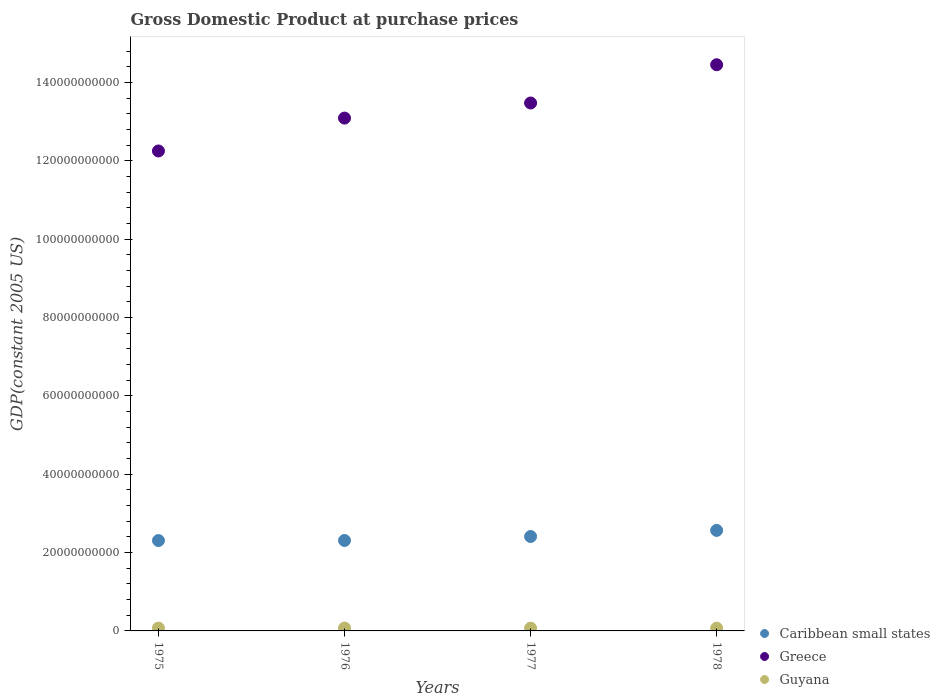How many different coloured dotlines are there?
Make the answer very short. 3. What is the GDP at purchase prices in Caribbean small states in 1976?
Keep it short and to the point. 2.31e+1. Across all years, what is the maximum GDP at purchase prices in Guyana?
Keep it short and to the point. 7.30e+08. Across all years, what is the minimum GDP at purchase prices in Guyana?
Your answer should be very brief. 6.98e+08. In which year was the GDP at purchase prices in Greece maximum?
Provide a succinct answer. 1978. In which year was the GDP at purchase prices in Greece minimum?
Ensure brevity in your answer.  1975. What is the total GDP at purchase prices in Guyana in the graph?
Your response must be concise. 2.86e+09. What is the difference between the GDP at purchase prices in Greece in 1976 and that in 1977?
Offer a very short reply. -3.85e+09. What is the difference between the GDP at purchase prices in Caribbean small states in 1975 and the GDP at purchase prices in Guyana in 1978?
Provide a succinct answer. 2.24e+1. What is the average GDP at purchase prices in Guyana per year?
Offer a very short reply. 7.14e+08. In the year 1976, what is the difference between the GDP at purchase prices in Caribbean small states and GDP at purchase prices in Greece?
Provide a succinct answer. -1.08e+11. What is the ratio of the GDP at purchase prices in Guyana in 1976 to that in 1978?
Keep it short and to the point. 1.05. Is the difference between the GDP at purchase prices in Caribbean small states in 1976 and 1978 greater than the difference between the GDP at purchase prices in Greece in 1976 and 1978?
Keep it short and to the point. Yes. What is the difference between the highest and the second highest GDP at purchase prices in Caribbean small states?
Offer a terse response. 1.56e+09. What is the difference between the highest and the lowest GDP at purchase prices in Caribbean small states?
Your answer should be compact. 2.59e+09. Is the sum of the GDP at purchase prices in Greece in 1975 and 1977 greater than the maximum GDP at purchase prices in Guyana across all years?
Offer a very short reply. Yes. Is the GDP at purchase prices in Guyana strictly less than the GDP at purchase prices in Greece over the years?
Your answer should be compact. Yes. What is the difference between two consecutive major ticks on the Y-axis?
Provide a succinct answer. 2.00e+1. Are the values on the major ticks of Y-axis written in scientific E-notation?
Provide a succinct answer. No. Does the graph contain any zero values?
Give a very brief answer. No. How many legend labels are there?
Your answer should be compact. 3. What is the title of the graph?
Provide a succinct answer. Gross Domestic Product at purchase prices. Does "Liberia" appear as one of the legend labels in the graph?
Give a very brief answer. No. What is the label or title of the X-axis?
Your answer should be very brief. Years. What is the label or title of the Y-axis?
Offer a terse response. GDP(constant 2005 US). What is the GDP(constant 2005 US) of Caribbean small states in 1975?
Keep it short and to the point. 2.31e+1. What is the GDP(constant 2005 US) in Greece in 1975?
Your answer should be compact. 1.23e+11. What is the GDP(constant 2005 US) of Guyana in 1975?
Ensure brevity in your answer.  7.19e+08. What is the GDP(constant 2005 US) of Caribbean small states in 1976?
Give a very brief answer. 2.31e+1. What is the GDP(constant 2005 US) in Greece in 1976?
Offer a terse response. 1.31e+11. What is the GDP(constant 2005 US) of Guyana in 1976?
Your response must be concise. 7.30e+08. What is the GDP(constant 2005 US) of Caribbean small states in 1977?
Offer a very short reply. 2.41e+1. What is the GDP(constant 2005 US) in Greece in 1977?
Your answer should be compact. 1.35e+11. What is the GDP(constant 2005 US) in Guyana in 1977?
Your answer should be compact. 7.11e+08. What is the GDP(constant 2005 US) of Caribbean small states in 1978?
Offer a terse response. 2.57e+1. What is the GDP(constant 2005 US) of Greece in 1978?
Your answer should be compact. 1.45e+11. What is the GDP(constant 2005 US) in Guyana in 1978?
Your response must be concise. 6.98e+08. Across all years, what is the maximum GDP(constant 2005 US) of Caribbean small states?
Your answer should be very brief. 2.57e+1. Across all years, what is the maximum GDP(constant 2005 US) of Greece?
Your response must be concise. 1.45e+11. Across all years, what is the maximum GDP(constant 2005 US) of Guyana?
Ensure brevity in your answer.  7.30e+08. Across all years, what is the minimum GDP(constant 2005 US) of Caribbean small states?
Your response must be concise. 2.31e+1. Across all years, what is the minimum GDP(constant 2005 US) of Greece?
Ensure brevity in your answer.  1.23e+11. Across all years, what is the minimum GDP(constant 2005 US) in Guyana?
Make the answer very short. 6.98e+08. What is the total GDP(constant 2005 US) in Caribbean small states in the graph?
Your response must be concise. 9.59e+1. What is the total GDP(constant 2005 US) in Greece in the graph?
Make the answer very short. 5.33e+11. What is the total GDP(constant 2005 US) of Guyana in the graph?
Keep it short and to the point. 2.86e+09. What is the difference between the GDP(constant 2005 US) of Caribbean small states in 1975 and that in 1976?
Your answer should be compact. -1.95e+07. What is the difference between the GDP(constant 2005 US) of Greece in 1975 and that in 1976?
Make the answer very short. -8.40e+09. What is the difference between the GDP(constant 2005 US) in Guyana in 1975 and that in 1976?
Your answer should be compact. -1.10e+07. What is the difference between the GDP(constant 2005 US) of Caribbean small states in 1975 and that in 1977?
Make the answer very short. -1.03e+09. What is the difference between the GDP(constant 2005 US) of Greece in 1975 and that in 1977?
Your answer should be very brief. -1.22e+1. What is the difference between the GDP(constant 2005 US) of Guyana in 1975 and that in 1977?
Offer a very short reply. 8.21e+06. What is the difference between the GDP(constant 2005 US) in Caribbean small states in 1975 and that in 1978?
Offer a terse response. -2.59e+09. What is the difference between the GDP(constant 2005 US) in Greece in 1975 and that in 1978?
Your response must be concise. -2.20e+1. What is the difference between the GDP(constant 2005 US) of Guyana in 1975 and that in 1978?
Make the answer very short. 2.10e+07. What is the difference between the GDP(constant 2005 US) of Caribbean small states in 1976 and that in 1977?
Your response must be concise. -1.01e+09. What is the difference between the GDP(constant 2005 US) of Greece in 1976 and that in 1977?
Your answer should be compact. -3.85e+09. What is the difference between the GDP(constant 2005 US) in Guyana in 1976 and that in 1977?
Give a very brief answer. 1.93e+07. What is the difference between the GDP(constant 2005 US) in Caribbean small states in 1976 and that in 1978?
Your answer should be compact. -2.57e+09. What is the difference between the GDP(constant 2005 US) in Greece in 1976 and that in 1978?
Ensure brevity in your answer.  -1.36e+1. What is the difference between the GDP(constant 2005 US) of Guyana in 1976 and that in 1978?
Provide a succinct answer. 3.21e+07. What is the difference between the GDP(constant 2005 US) of Caribbean small states in 1977 and that in 1978?
Ensure brevity in your answer.  -1.56e+09. What is the difference between the GDP(constant 2005 US) in Greece in 1977 and that in 1978?
Your answer should be compact. -9.77e+09. What is the difference between the GDP(constant 2005 US) in Guyana in 1977 and that in 1978?
Your answer should be very brief. 1.28e+07. What is the difference between the GDP(constant 2005 US) in Caribbean small states in 1975 and the GDP(constant 2005 US) in Greece in 1976?
Offer a very short reply. -1.08e+11. What is the difference between the GDP(constant 2005 US) in Caribbean small states in 1975 and the GDP(constant 2005 US) in Guyana in 1976?
Provide a short and direct response. 2.23e+1. What is the difference between the GDP(constant 2005 US) of Greece in 1975 and the GDP(constant 2005 US) of Guyana in 1976?
Your response must be concise. 1.22e+11. What is the difference between the GDP(constant 2005 US) in Caribbean small states in 1975 and the GDP(constant 2005 US) in Greece in 1977?
Your answer should be very brief. -1.12e+11. What is the difference between the GDP(constant 2005 US) of Caribbean small states in 1975 and the GDP(constant 2005 US) of Guyana in 1977?
Your answer should be very brief. 2.24e+1. What is the difference between the GDP(constant 2005 US) in Greece in 1975 and the GDP(constant 2005 US) in Guyana in 1977?
Offer a terse response. 1.22e+11. What is the difference between the GDP(constant 2005 US) in Caribbean small states in 1975 and the GDP(constant 2005 US) in Greece in 1978?
Your answer should be very brief. -1.21e+11. What is the difference between the GDP(constant 2005 US) of Caribbean small states in 1975 and the GDP(constant 2005 US) of Guyana in 1978?
Provide a short and direct response. 2.24e+1. What is the difference between the GDP(constant 2005 US) in Greece in 1975 and the GDP(constant 2005 US) in Guyana in 1978?
Offer a very short reply. 1.22e+11. What is the difference between the GDP(constant 2005 US) of Caribbean small states in 1976 and the GDP(constant 2005 US) of Greece in 1977?
Offer a very short reply. -1.12e+11. What is the difference between the GDP(constant 2005 US) in Caribbean small states in 1976 and the GDP(constant 2005 US) in Guyana in 1977?
Offer a very short reply. 2.24e+1. What is the difference between the GDP(constant 2005 US) in Greece in 1976 and the GDP(constant 2005 US) in Guyana in 1977?
Your answer should be compact. 1.30e+11. What is the difference between the GDP(constant 2005 US) in Caribbean small states in 1976 and the GDP(constant 2005 US) in Greece in 1978?
Your answer should be very brief. -1.21e+11. What is the difference between the GDP(constant 2005 US) in Caribbean small states in 1976 and the GDP(constant 2005 US) in Guyana in 1978?
Provide a succinct answer. 2.24e+1. What is the difference between the GDP(constant 2005 US) in Greece in 1976 and the GDP(constant 2005 US) in Guyana in 1978?
Ensure brevity in your answer.  1.30e+11. What is the difference between the GDP(constant 2005 US) in Caribbean small states in 1977 and the GDP(constant 2005 US) in Greece in 1978?
Your response must be concise. -1.20e+11. What is the difference between the GDP(constant 2005 US) of Caribbean small states in 1977 and the GDP(constant 2005 US) of Guyana in 1978?
Offer a very short reply. 2.34e+1. What is the difference between the GDP(constant 2005 US) in Greece in 1977 and the GDP(constant 2005 US) in Guyana in 1978?
Offer a terse response. 1.34e+11. What is the average GDP(constant 2005 US) of Caribbean small states per year?
Ensure brevity in your answer.  2.40e+1. What is the average GDP(constant 2005 US) in Greece per year?
Make the answer very short. 1.33e+11. What is the average GDP(constant 2005 US) of Guyana per year?
Offer a very short reply. 7.14e+08. In the year 1975, what is the difference between the GDP(constant 2005 US) of Caribbean small states and GDP(constant 2005 US) of Greece?
Make the answer very short. -9.95e+1. In the year 1975, what is the difference between the GDP(constant 2005 US) of Caribbean small states and GDP(constant 2005 US) of Guyana?
Give a very brief answer. 2.24e+1. In the year 1975, what is the difference between the GDP(constant 2005 US) of Greece and GDP(constant 2005 US) of Guyana?
Ensure brevity in your answer.  1.22e+11. In the year 1976, what is the difference between the GDP(constant 2005 US) of Caribbean small states and GDP(constant 2005 US) of Greece?
Give a very brief answer. -1.08e+11. In the year 1976, what is the difference between the GDP(constant 2005 US) in Caribbean small states and GDP(constant 2005 US) in Guyana?
Provide a succinct answer. 2.24e+1. In the year 1976, what is the difference between the GDP(constant 2005 US) of Greece and GDP(constant 2005 US) of Guyana?
Your response must be concise. 1.30e+11. In the year 1977, what is the difference between the GDP(constant 2005 US) of Caribbean small states and GDP(constant 2005 US) of Greece?
Your answer should be very brief. -1.11e+11. In the year 1977, what is the difference between the GDP(constant 2005 US) of Caribbean small states and GDP(constant 2005 US) of Guyana?
Your answer should be very brief. 2.34e+1. In the year 1977, what is the difference between the GDP(constant 2005 US) of Greece and GDP(constant 2005 US) of Guyana?
Provide a short and direct response. 1.34e+11. In the year 1978, what is the difference between the GDP(constant 2005 US) of Caribbean small states and GDP(constant 2005 US) of Greece?
Ensure brevity in your answer.  -1.19e+11. In the year 1978, what is the difference between the GDP(constant 2005 US) of Caribbean small states and GDP(constant 2005 US) of Guyana?
Ensure brevity in your answer.  2.50e+1. In the year 1978, what is the difference between the GDP(constant 2005 US) in Greece and GDP(constant 2005 US) in Guyana?
Your answer should be compact. 1.44e+11. What is the ratio of the GDP(constant 2005 US) in Greece in 1975 to that in 1976?
Ensure brevity in your answer.  0.94. What is the ratio of the GDP(constant 2005 US) of Guyana in 1975 to that in 1976?
Your response must be concise. 0.98. What is the ratio of the GDP(constant 2005 US) of Caribbean small states in 1975 to that in 1977?
Offer a very short reply. 0.96. What is the ratio of the GDP(constant 2005 US) of Greece in 1975 to that in 1977?
Ensure brevity in your answer.  0.91. What is the ratio of the GDP(constant 2005 US) of Guyana in 1975 to that in 1977?
Provide a succinct answer. 1.01. What is the ratio of the GDP(constant 2005 US) in Caribbean small states in 1975 to that in 1978?
Give a very brief answer. 0.9. What is the ratio of the GDP(constant 2005 US) of Greece in 1975 to that in 1978?
Provide a succinct answer. 0.85. What is the ratio of the GDP(constant 2005 US) in Guyana in 1975 to that in 1978?
Offer a terse response. 1.03. What is the ratio of the GDP(constant 2005 US) of Caribbean small states in 1976 to that in 1977?
Offer a terse response. 0.96. What is the ratio of the GDP(constant 2005 US) of Greece in 1976 to that in 1977?
Provide a succinct answer. 0.97. What is the ratio of the GDP(constant 2005 US) in Guyana in 1976 to that in 1977?
Provide a succinct answer. 1.03. What is the ratio of the GDP(constant 2005 US) in Caribbean small states in 1976 to that in 1978?
Your response must be concise. 0.9. What is the ratio of the GDP(constant 2005 US) of Greece in 1976 to that in 1978?
Offer a terse response. 0.91. What is the ratio of the GDP(constant 2005 US) in Guyana in 1976 to that in 1978?
Offer a very short reply. 1.05. What is the ratio of the GDP(constant 2005 US) of Caribbean small states in 1977 to that in 1978?
Make the answer very short. 0.94. What is the ratio of the GDP(constant 2005 US) of Greece in 1977 to that in 1978?
Offer a very short reply. 0.93. What is the ratio of the GDP(constant 2005 US) of Guyana in 1977 to that in 1978?
Offer a terse response. 1.02. What is the difference between the highest and the second highest GDP(constant 2005 US) in Caribbean small states?
Provide a succinct answer. 1.56e+09. What is the difference between the highest and the second highest GDP(constant 2005 US) of Greece?
Your answer should be very brief. 9.77e+09. What is the difference between the highest and the second highest GDP(constant 2005 US) of Guyana?
Give a very brief answer. 1.10e+07. What is the difference between the highest and the lowest GDP(constant 2005 US) in Caribbean small states?
Your response must be concise. 2.59e+09. What is the difference between the highest and the lowest GDP(constant 2005 US) in Greece?
Make the answer very short. 2.20e+1. What is the difference between the highest and the lowest GDP(constant 2005 US) of Guyana?
Provide a short and direct response. 3.21e+07. 